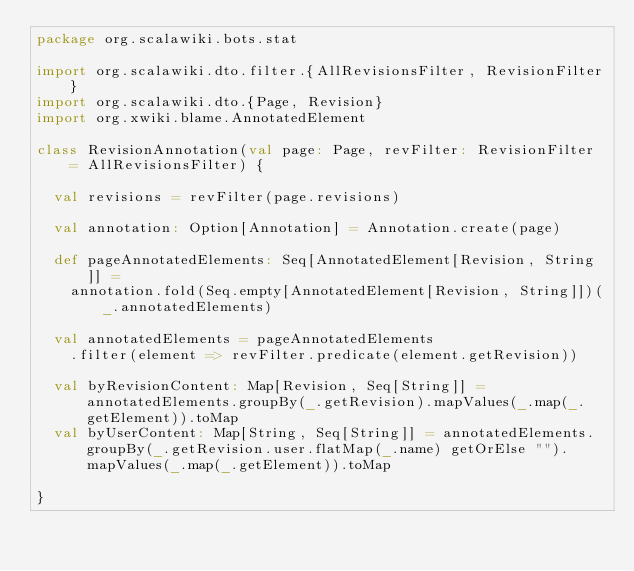<code> <loc_0><loc_0><loc_500><loc_500><_Scala_>package org.scalawiki.bots.stat

import org.scalawiki.dto.filter.{AllRevisionsFilter, RevisionFilter}
import org.scalawiki.dto.{Page, Revision}
import org.xwiki.blame.AnnotatedElement

class RevisionAnnotation(val page: Page, revFilter: RevisionFilter = AllRevisionsFilter) {

  val revisions = revFilter(page.revisions)

  val annotation: Option[Annotation] = Annotation.create(page)

  def pageAnnotatedElements: Seq[AnnotatedElement[Revision, String]] =
    annotation.fold(Seq.empty[AnnotatedElement[Revision, String]])(_.annotatedElements)

  val annotatedElements = pageAnnotatedElements
    .filter(element => revFilter.predicate(element.getRevision))

  val byRevisionContent: Map[Revision, Seq[String]] = annotatedElements.groupBy(_.getRevision).mapValues(_.map(_.getElement)).toMap
  val byUserContent: Map[String, Seq[String]] = annotatedElements.groupBy(_.getRevision.user.flatMap(_.name) getOrElse "").mapValues(_.map(_.getElement)).toMap

}
</code> 